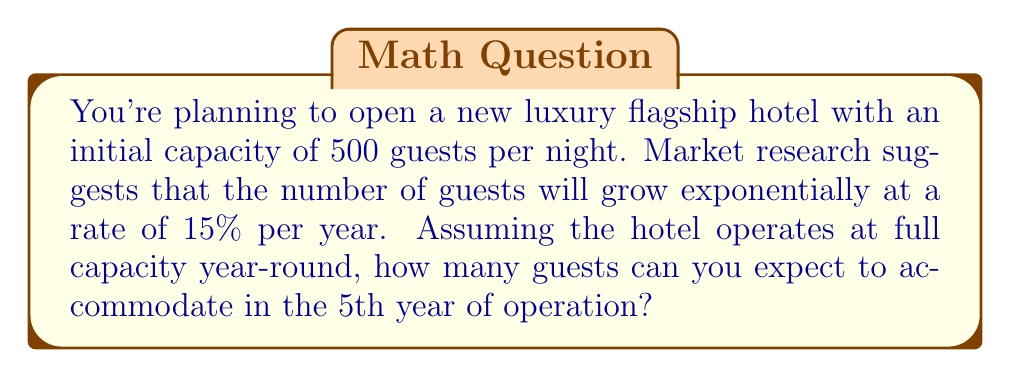What is the answer to this math problem? To solve this problem, we'll use the exponential growth model:

$$ A = P(1 + r)^t $$

Where:
$A$ = Final amount
$P$ = Initial amount
$r$ = Growth rate (as a decimal)
$t$ = Time period

Given:
$P = 500 \times 365 = 182,500$ (initial guests per year)
$r = 0.15$ (15% growth rate)
$t = 5$ (5th year of operation)

Let's calculate:

$$ A = 182,500(1 + 0.15)^5 $$

$$ A = 182,500(1.15)^5 $$

$$ A = 182,500(2.0113) $$

$$ A = 366,862.25 $$

Since we can't have a fractional guest, we round down to the nearest whole number.
Answer: 366,862 guests 